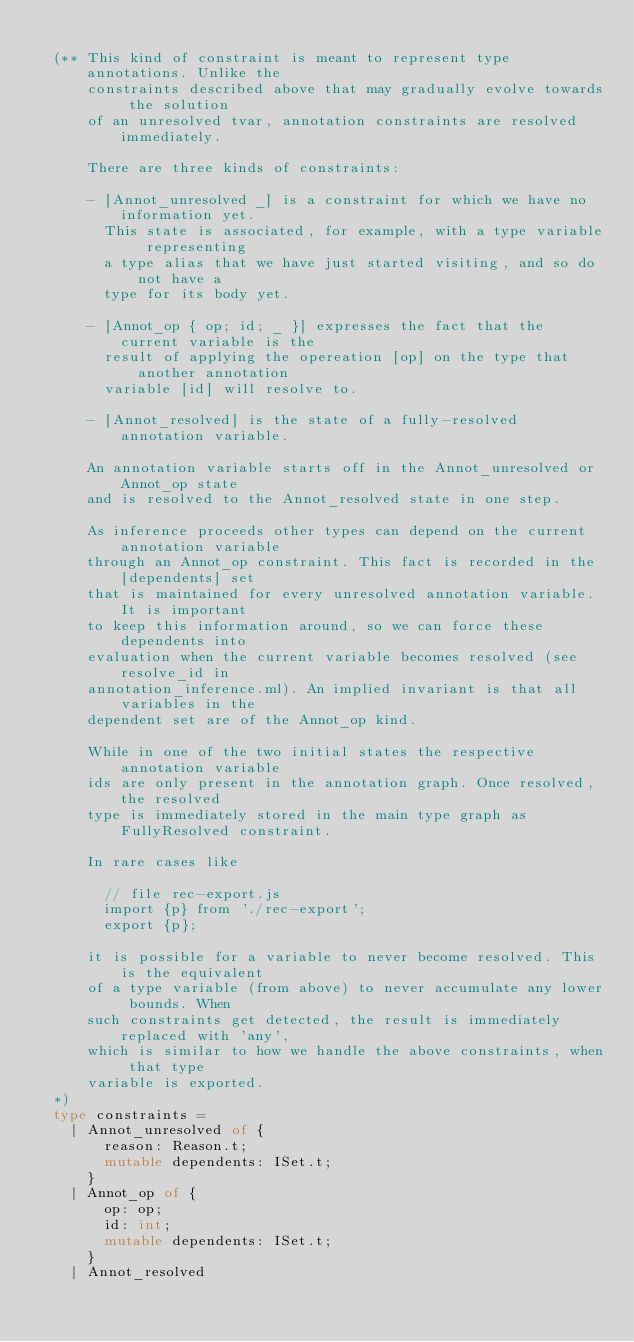<code> <loc_0><loc_0><loc_500><loc_500><_OCaml_>
  (** This kind of constraint is meant to represent type annotations. Unlike the
      constraints described above that may gradually evolve towards the solution
      of an unresolved tvar, annotation constraints are resolved immediately.

      There are three kinds of constraints:

      - [Annot_unresolved _] is a constraint for which we have no information yet.
        This state is associated, for example, with a type variable representing
        a type alias that we have just started visiting, and so do not have a
        type for its body yet.

      - [Annot_op { op; id; _ }] expresses the fact that the current variable is the
        result of applying the opereation [op] on the type that another annotation
        variable [id] will resolve to.

      - [Annot_resolved] is the state of a fully-resolved annotation variable.

      An annotation variable starts off in the Annot_unresolved or Annot_op state
      and is resolved to the Annot_resolved state in one step.

      As inference proceeds other types can depend on the current annotation variable
      through an Annot_op constraint. This fact is recorded in the [dependents] set
      that is maintained for every unresolved annotation variable. It is important
      to keep this information around, so we can force these dependents into
      evaluation when the current variable becomes resolved (see resolve_id in
      annotation_inference.ml). An implied invariant is that all variables in the
      dependent set are of the Annot_op kind.

      While in one of the two initial states the respective annotation variable
      ids are only present in the annotation graph. Once resolved, the resolved
      type is immediately stored in the main type graph as FullyResolved constraint.

      In rare cases like

        // file rec-export.js
        import {p} from './rec-export';
        export {p};

      it is possible for a variable to never become resolved. This is the equivalent
      of a type variable (from above) to never accumulate any lower bounds. When
      such constraints get detected, the result is immediately replaced with 'any',
      which is similar to how we handle the above constraints, when that type
      variable is exported.
  *)
  type constraints =
    | Annot_unresolved of {
        reason: Reason.t;
        mutable dependents: ISet.t;
      }
    | Annot_op of {
        op: op;
        id: int;
        mutable dependents: ISet.t;
      }
    | Annot_resolved
</code> 